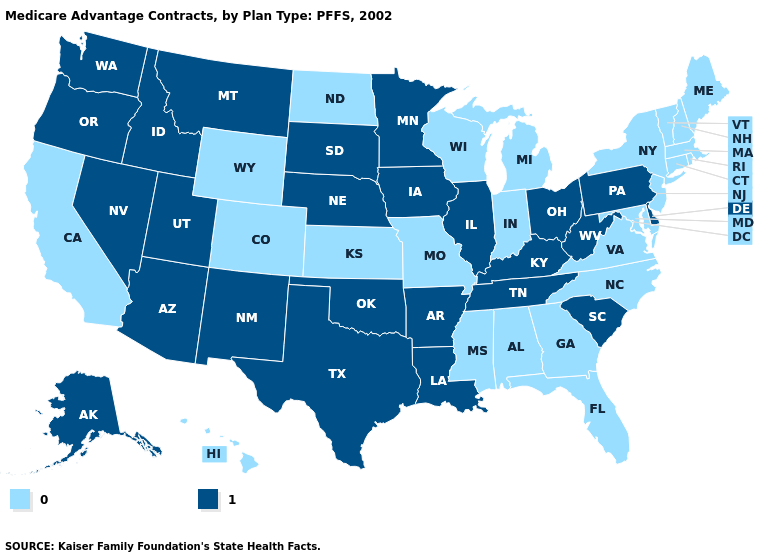What is the lowest value in the USA?
Give a very brief answer. 0. Does Kansas have the highest value in the USA?
Keep it brief. No. Does the map have missing data?
Answer briefly. No. What is the value of New Hampshire?
Concise answer only. 0. Name the states that have a value in the range 0?
Be succinct. Alabama, California, Colorado, Connecticut, Florida, Georgia, Hawaii, Indiana, Kansas, Massachusetts, Maryland, Maine, Michigan, Missouri, Mississippi, North Carolina, North Dakota, New Hampshire, New Jersey, New York, Rhode Island, Virginia, Vermont, Wisconsin, Wyoming. Does North Carolina have a higher value than Ohio?
Keep it brief. No. Does Indiana have the lowest value in the MidWest?
Keep it brief. Yes. Which states have the lowest value in the Northeast?
Quick response, please. Connecticut, Massachusetts, Maine, New Hampshire, New Jersey, New York, Rhode Island, Vermont. Does the map have missing data?
Keep it brief. No. What is the lowest value in the USA?
Short answer required. 0. Among the states that border Ohio , does West Virginia have the highest value?
Concise answer only. Yes. What is the lowest value in the West?
Keep it brief. 0. Which states have the highest value in the USA?
Be succinct. Alaska, Arkansas, Arizona, Delaware, Iowa, Idaho, Illinois, Kentucky, Louisiana, Minnesota, Montana, Nebraska, New Mexico, Nevada, Ohio, Oklahoma, Oregon, Pennsylvania, South Carolina, South Dakota, Tennessee, Texas, Utah, Washington, West Virginia. What is the value of Indiana?
Answer briefly. 0. Name the states that have a value in the range 0?
Answer briefly. Alabama, California, Colorado, Connecticut, Florida, Georgia, Hawaii, Indiana, Kansas, Massachusetts, Maryland, Maine, Michigan, Missouri, Mississippi, North Carolina, North Dakota, New Hampshire, New Jersey, New York, Rhode Island, Virginia, Vermont, Wisconsin, Wyoming. 